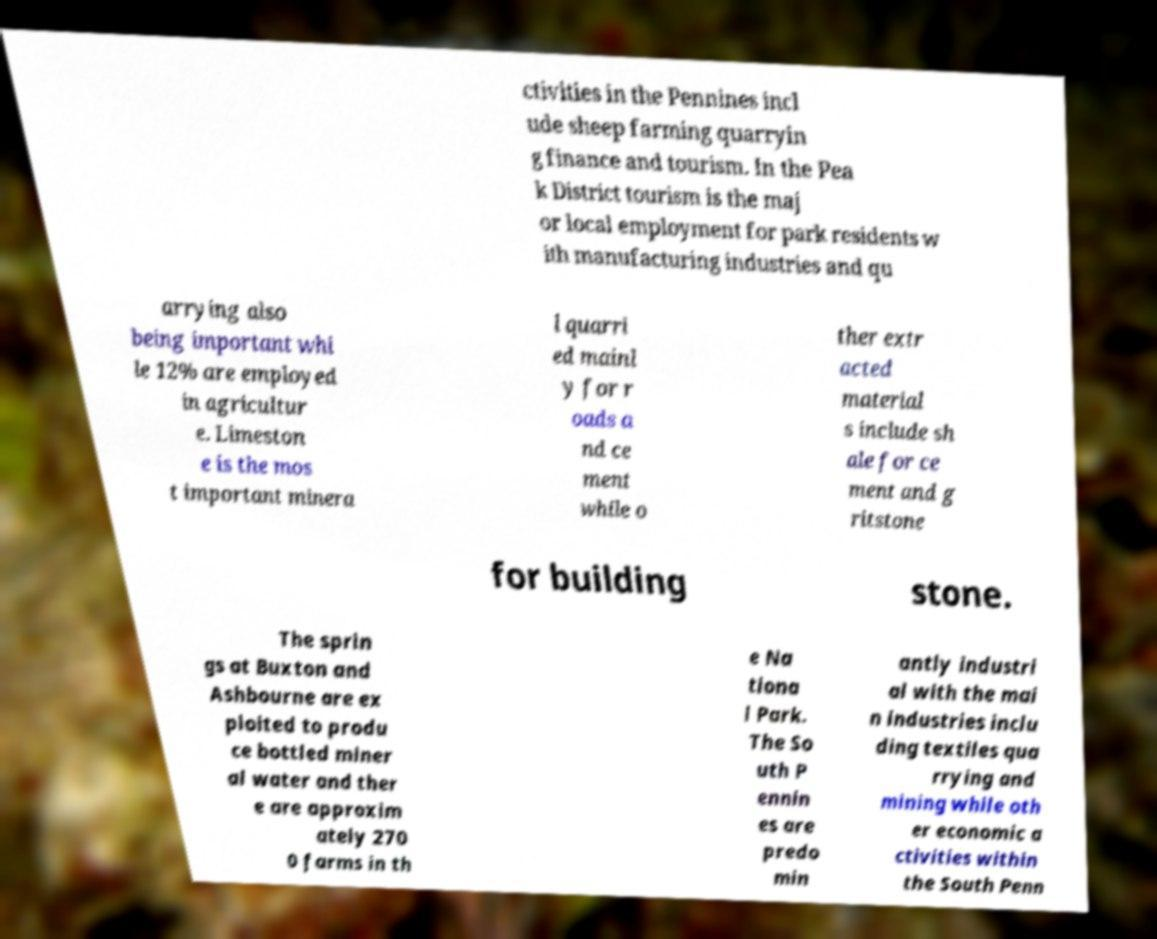What messages or text are displayed in this image? I need them in a readable, typed format. ctivities in the Pennines incl ude sheep farming quarryin g finance and tourism. In the Pea k District tourism is the maj or local employment for park residents w ith manufacturing industries and qu arrying also being important whi le 12% are employed in agricultur e. Limeston e is the mos t important minera l quarri ed mainl y for r oads a nd ce ment while o ther extr acted material s include sh ale for ce ment and g ritstone for building stone. The sprin gs at Buxton and Ashbourne are ex ploited to produ ce bottled miner al water and ther e are approxim ately 270 0 farms in th e Na tiona l Park. The So uth P ennin es are predo min antly industri al with the mai n industries inclu ding textiles qua rrying and mining while oth er economic a ctivities within the South Penn 